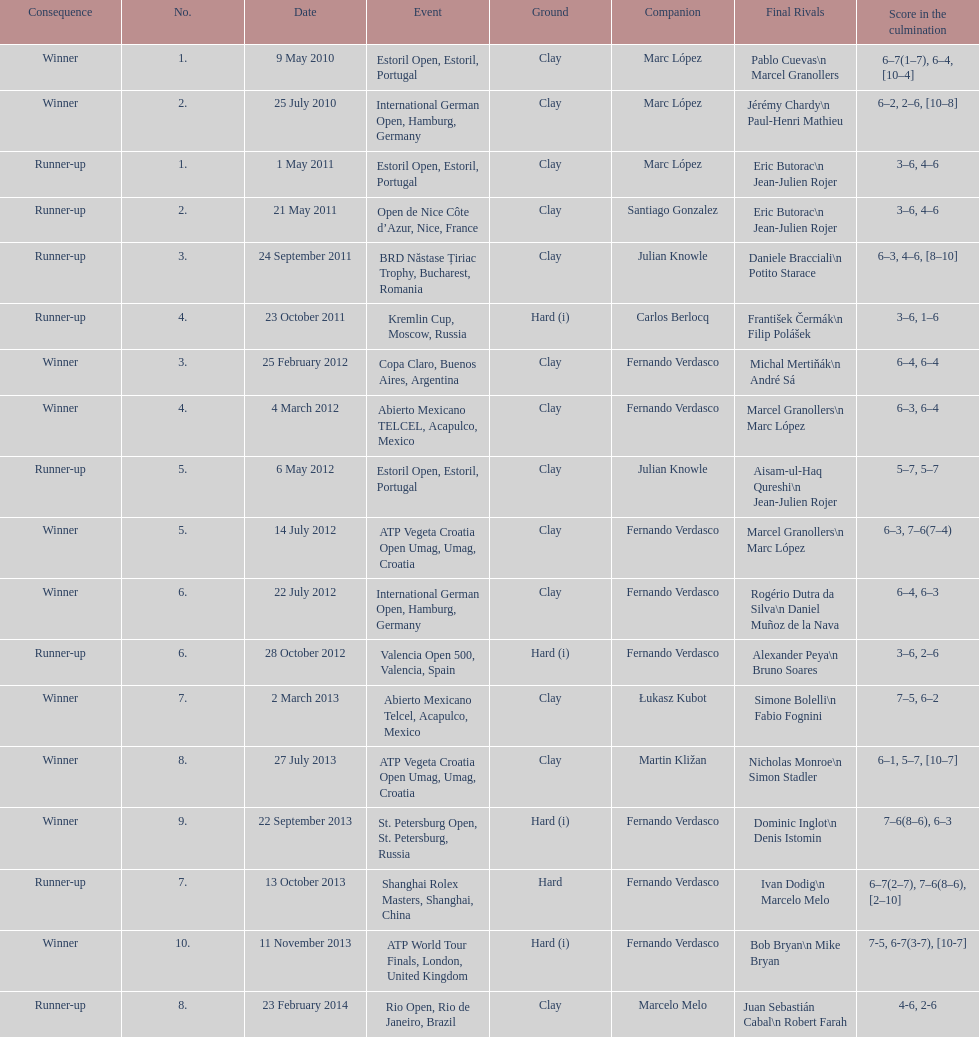What tournament was before the estoril open? Abierto Mexicano TELCEL, Acapulco, Mexico. 